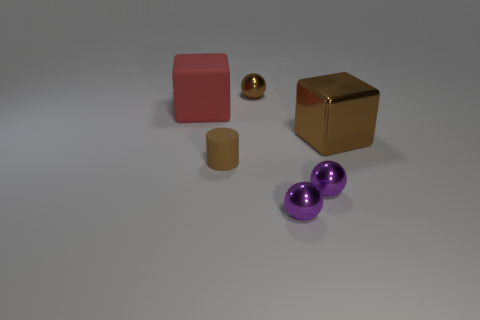Imagine these objects are part of a contemporary art installation. What could be the possible theme or message? If these objects were part of a contemporary art installation, the theme might revolve around the contrast of forms and textures. The combination of geometric clarity represented by the cubes and the organic feel of the rounded sphere and cylinder could signify the unity of human-made and natural elements. The variation in colors and materials might highlight diversity and coexistence, inviting viewers to reflect on the harmony of differences in the fabric of society. 